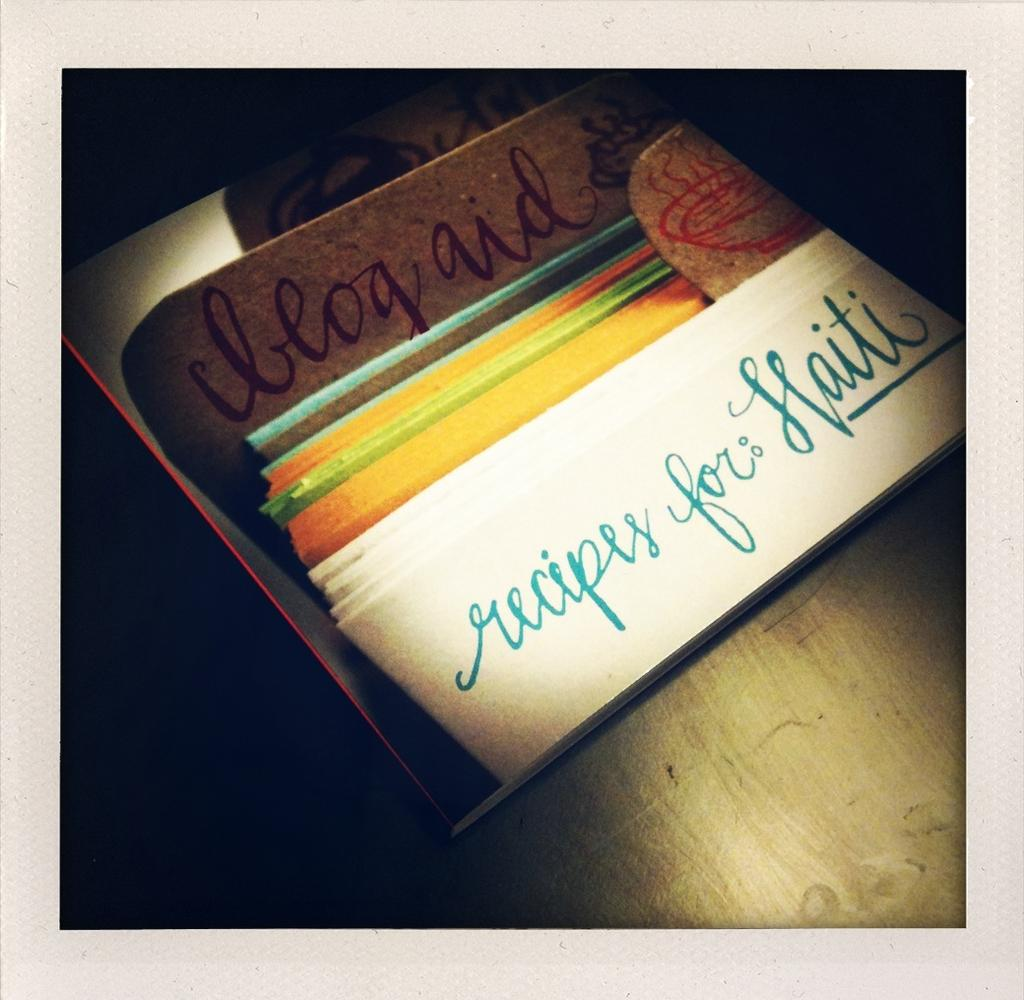<image>
Summarize the visual content of the image. A stack of papers is entitled recipes for: Haiti 